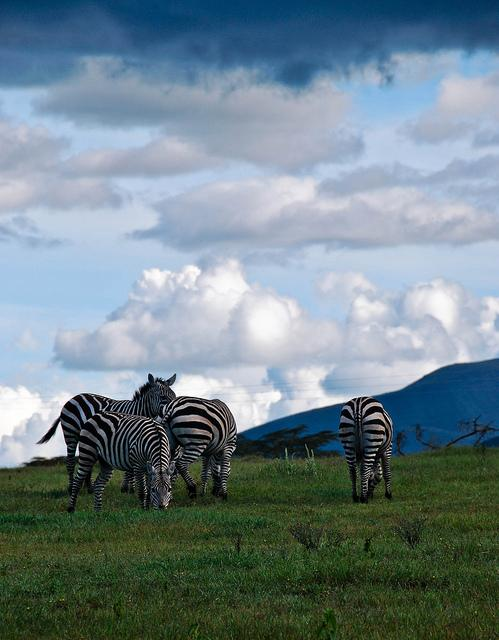How many zebras are grazing in the field before the mountain? four 